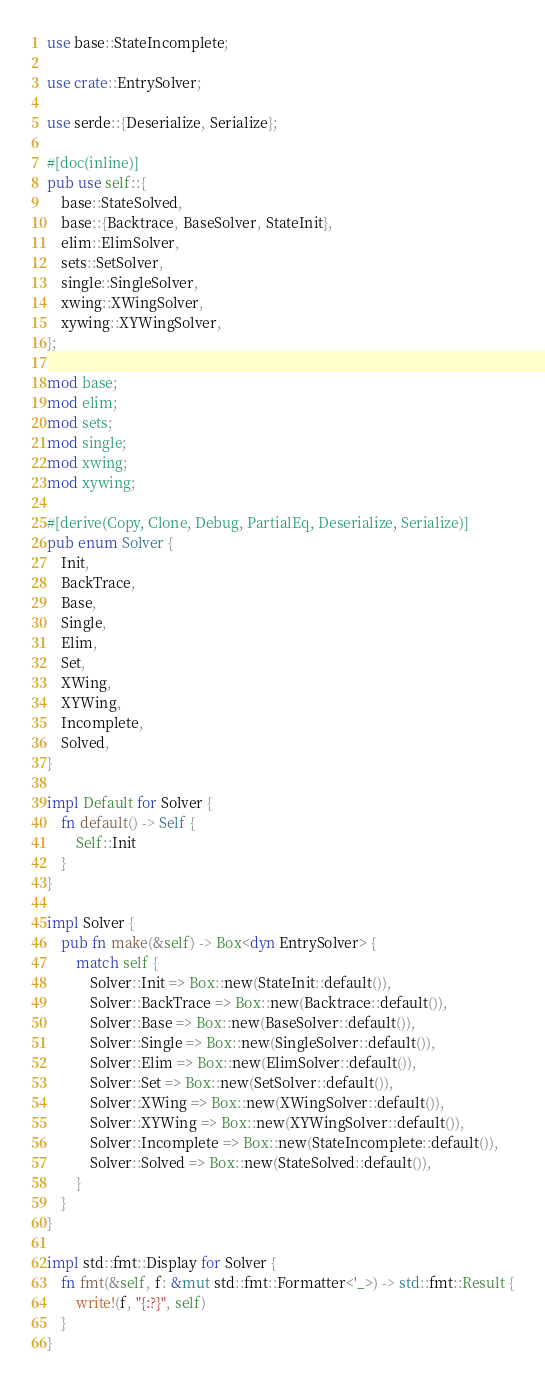<code> <loc_0><loc_0><loc_500><loc_500><_Rust_>use base::StateIncomplete;

use crate::EntrySolver;

use serde::{Deserialize, Serialize};

#[doc(inline)]
pub use self::{
    base::StateSolved,
    base::{Backtrace, BaseSolver, StateInit},
    elim::ElimSolver,
    sets::SetSolver,
    single::SingleSolver,
    xwing::XWingSolver,
    xywing::XYWingSolver,
};

mod base;
mod elim;
mod sets;
mod single;
mod xwing;
mod xywing;

#[derive(Copy, Clone, Debug, PartialEq, Deserialize, Serialize)]
pub enum Solver {
    Init,
    BackTrace,
    Base,
    Single,
    Elim,
    Set,
    XWing,
    XYWing,
    Incomplete,
    Solved,
}

impl Default for Solver {
    fn default() -> Self {
        Self::Init
    }
}

impl Solver {
    pub fn make(&self) -> Box<dyn EntrySolver> {
        match self {
            Solver::Init => Box::new(StateInit::default()),
            Solver::BackTrace => Box::new(Backtrace::default()),
            Solver::Base => Box::new(BaseSolver::default()),
            Solver::Single => Box::new(SingleSolver::default()),
            Solver::Elim => Box::new(ElimSolver::default()),
            Solver::Set => Box::new(SetSolver::default()),
            Solver::XWing => Box::new(XWingSolver::default()),
            Solver::XYWing => Box::new(XYWingSolver::default()),
            Solver::Incomplete => Box::new(StateIncomplete::default()),
            Solver::Solved => Box::new(StateSolved::default()),
        }
    }
}

impl std::fmt::Display for Solver {
    fn fmt(&self, f: &mut std::fmt::Formatter<'_>) -> std::fmt::Result {
        write!(f, "{:?}", self)
    }
}
</code> 